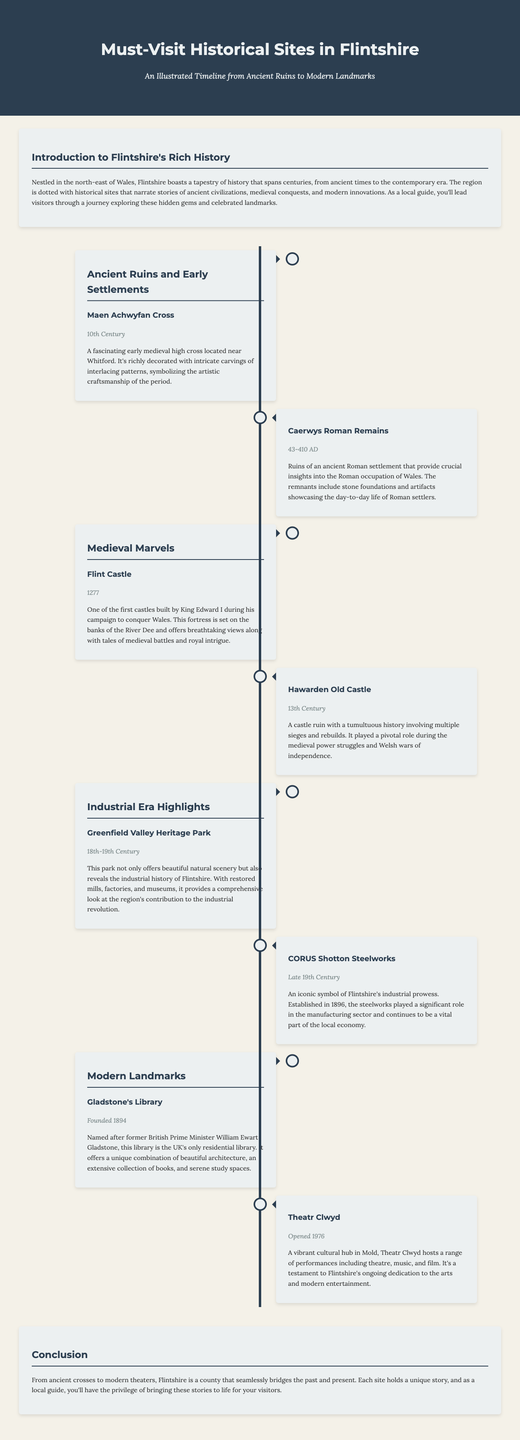What is the name of the library founded in 1894? The library named after former British Prime Minister William Ewart Gladstone is uniquely known as the UK's only residential library.
Answer: Gladstone's Library What century does the Maen Achwyfan Cross date back to? The Maen Achwyfan Cross is identified as a historical artifact from the 10th Century.
Answer: 10th Century What type of site is the Greenfield Valley Heritage Park? According to the document, this site offers both beautiful scenery and industrial history related to Flintshire's contributions during a vital era.
Answer: Heritage Park In what year was Theatr Clwyd opened? Theatr Clwyd is noted as having opened its doors to the public in the year 1976.
Answer: 1976 Which historical site is located near Whitford? The timeline item identifies the Maen Achwyfan Cross as being located in proximity to Whitford.
Answer: Maen Achwyfan Cross What was established in 1896 in Flintshire? The document notes that CORUS Shotton Steelworks was established in Flintshire during this year.
Answer: CORUS Shotton Steelworks What period do the Caerwys Roman Remains belong to? The ruins of Caerwys Roman Remains are linked to the time frame of Roman occupation in Wales.
Answer: 43-410 AD Which castle is one of the first built by King Edward I? Flint Castle is specifically mentioned as one of the initial castles constructed by King Edward I.
Answer: Flint Castle What century is associated with Hawarden Old Castle? Hawarden Old Castle is categorized as a historical site from the 13th Century.
Answer: 13th Century 